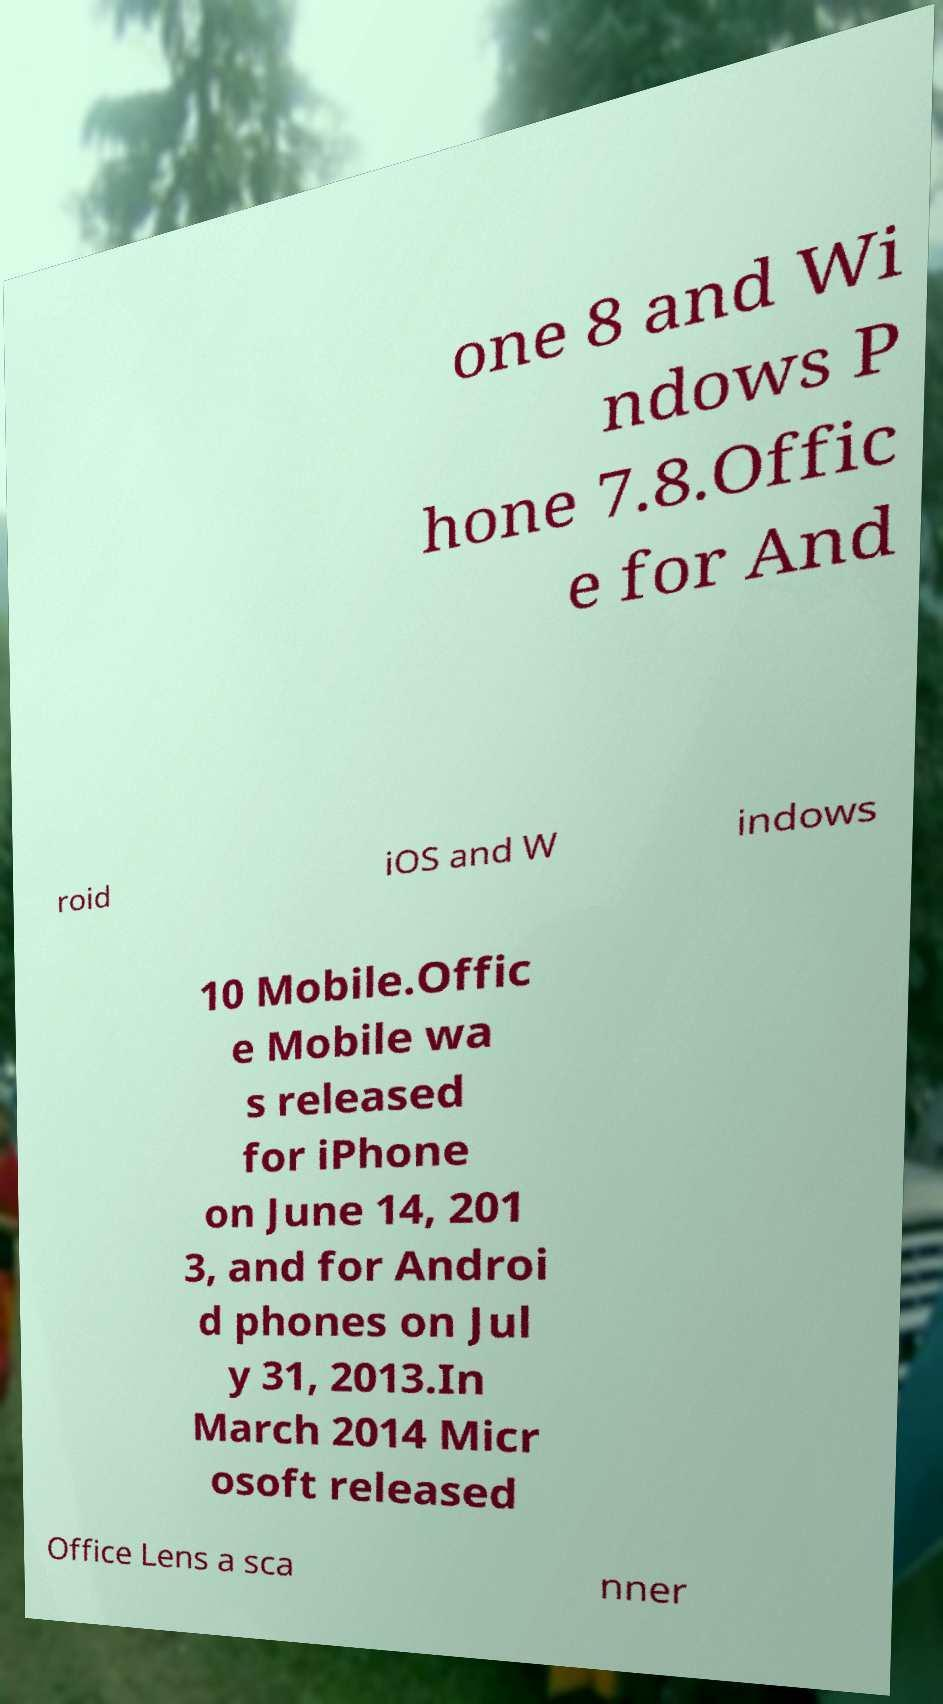There's text embedded in this image that I need extracted. Can you transcribe it verbatim? one 8 and Wi ndows P hone 7.8.Offic e for And roid iOS and W indows 10 Mobile.Offic e Mobile wa s released for iPhone on June 14, 201 3, and for Androi d phones on Jul y 31, 2013.In March 2014 Micr osoft released Office Lens a sca nner 